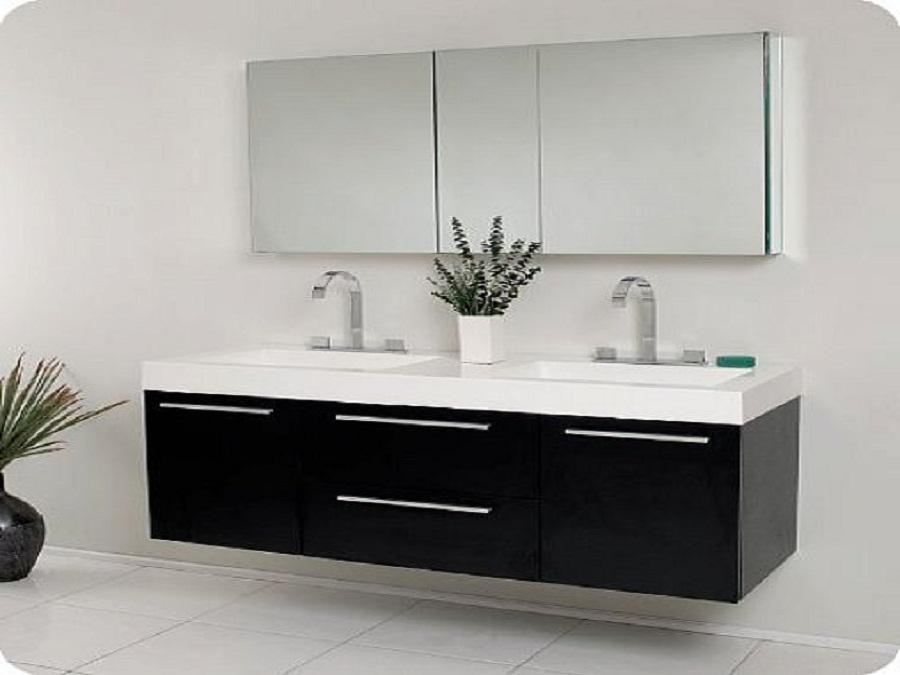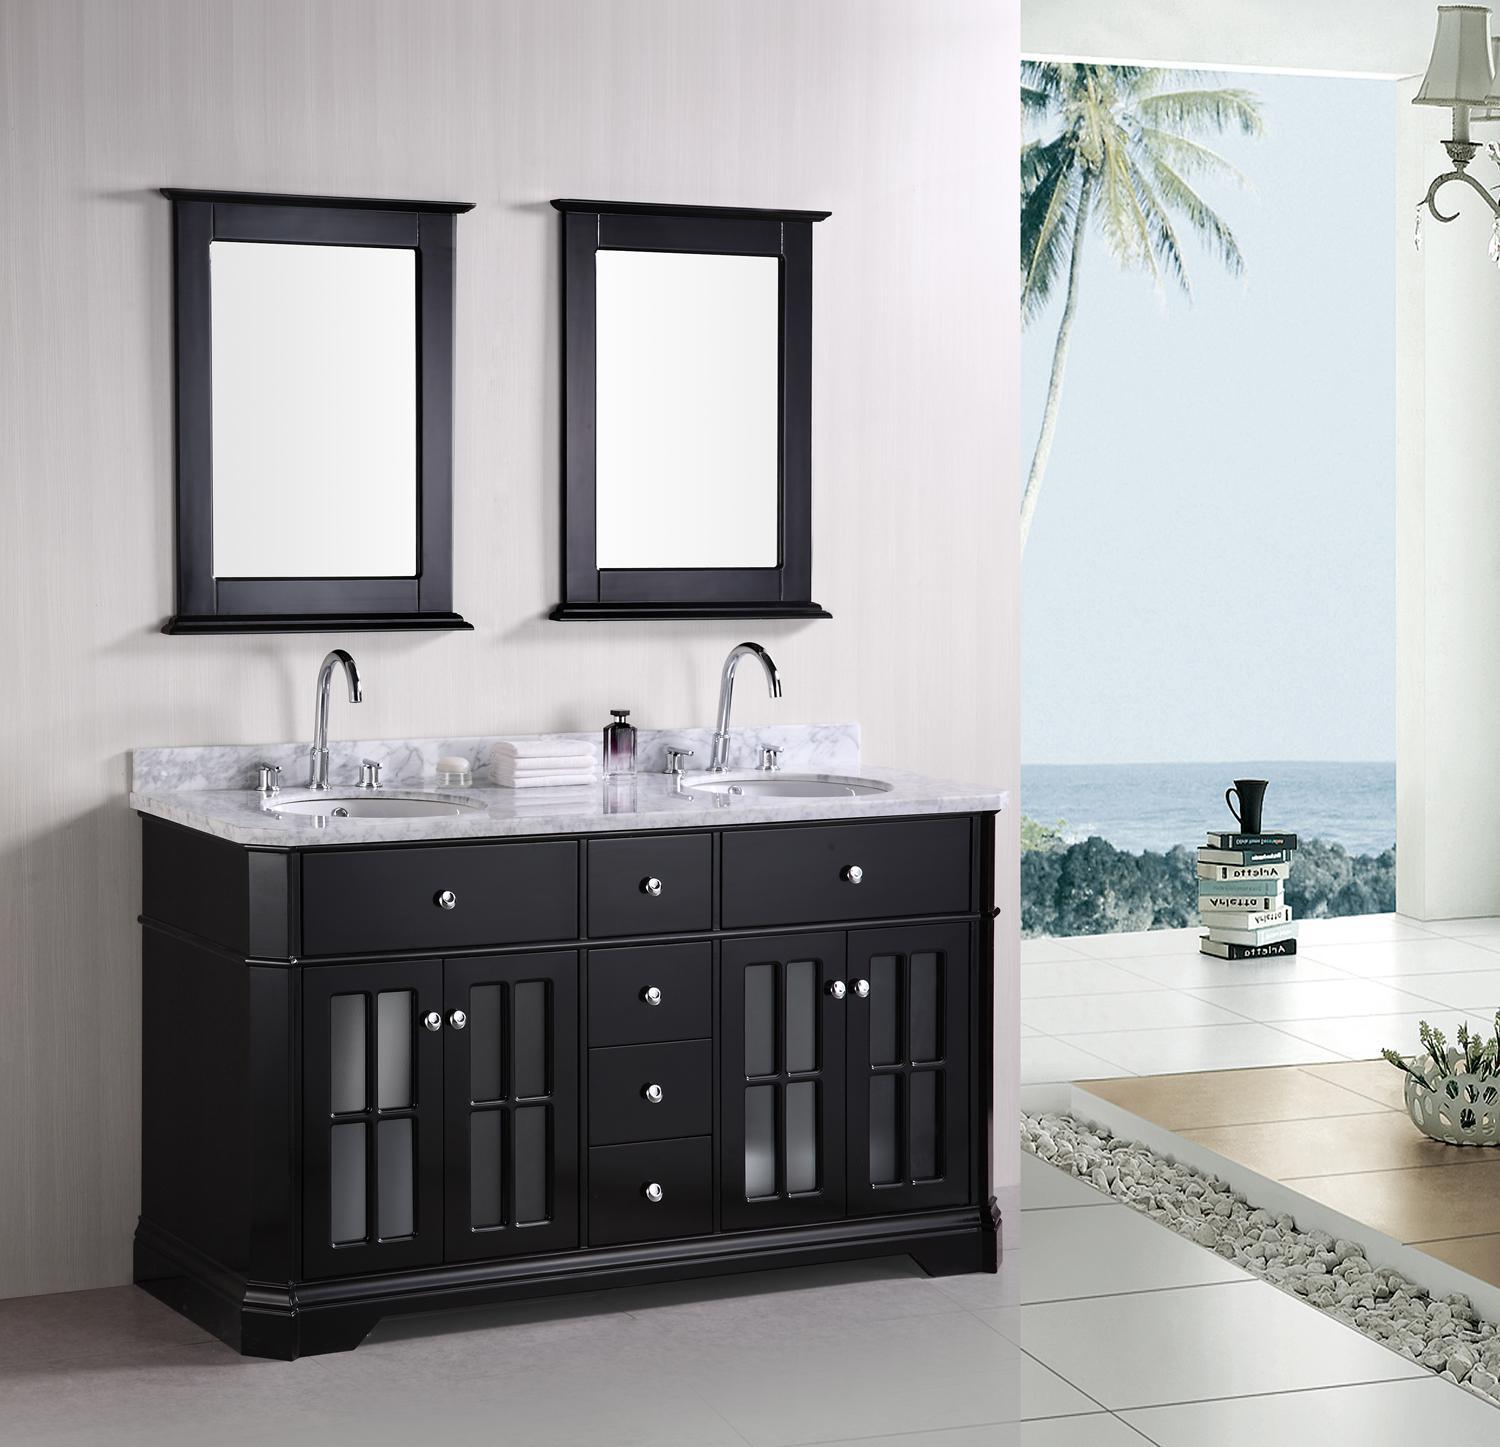The first image is the image on the left, the second image is the image on the right. Assess this claim about the two images: "The counter in the image on the left is black and has two white sinks.". Correct or not? Answer yes or no. No. 